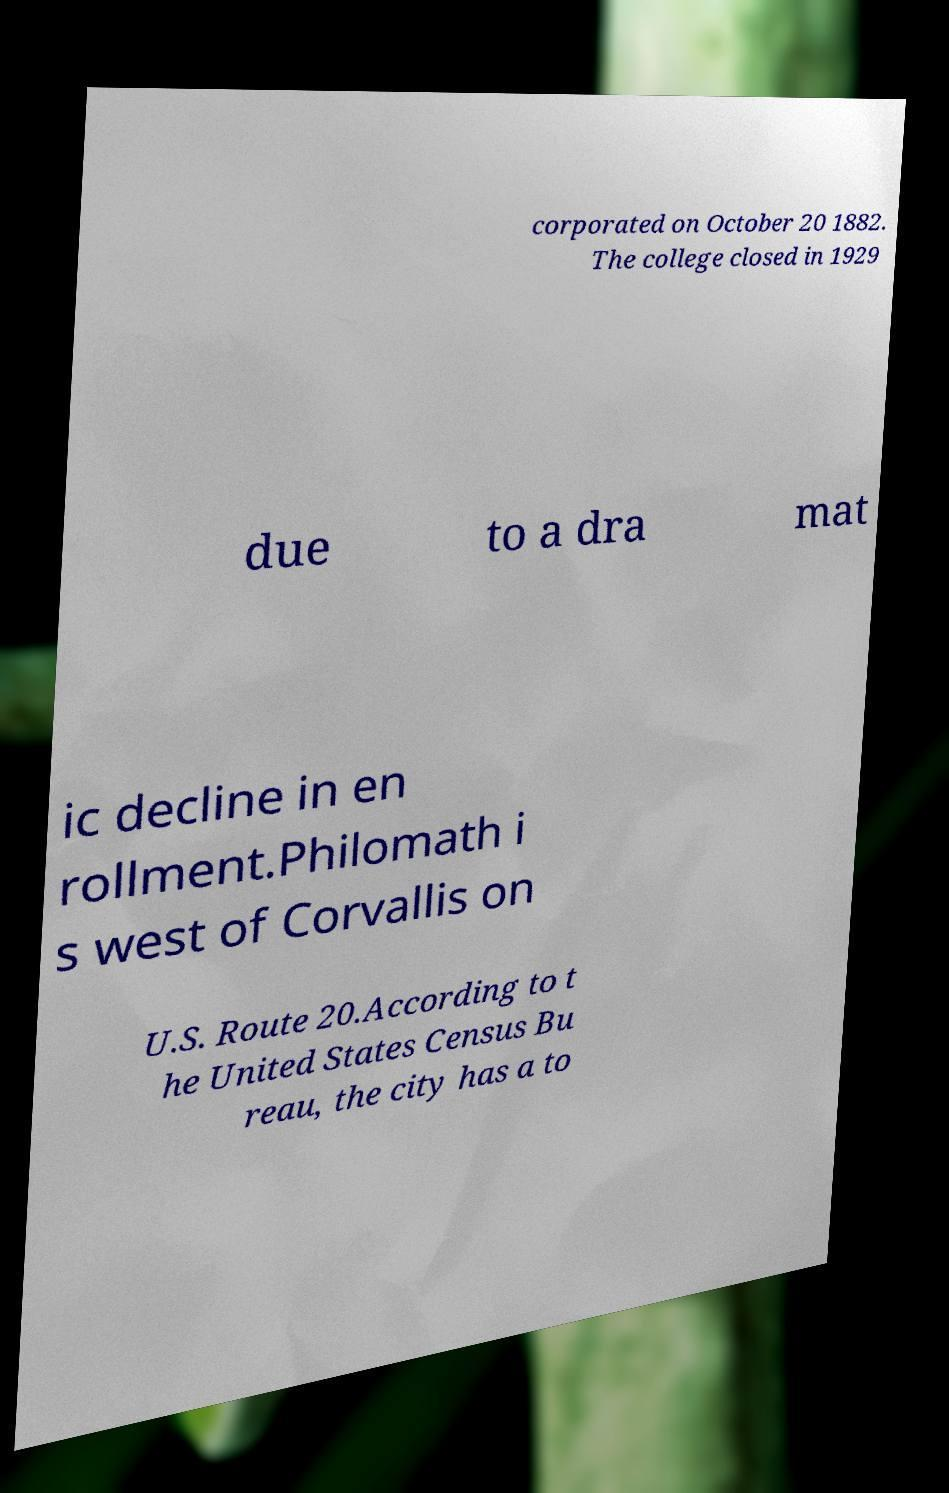Could you extract and type out the text from this image? corporated on October 20 1882. The college closed in 1929 due to a dra mat ic decline in en rollment.Philomath i s west of Corvallis on U.S. Route 20.According to t he United States Census Bu reau, the city has a to 